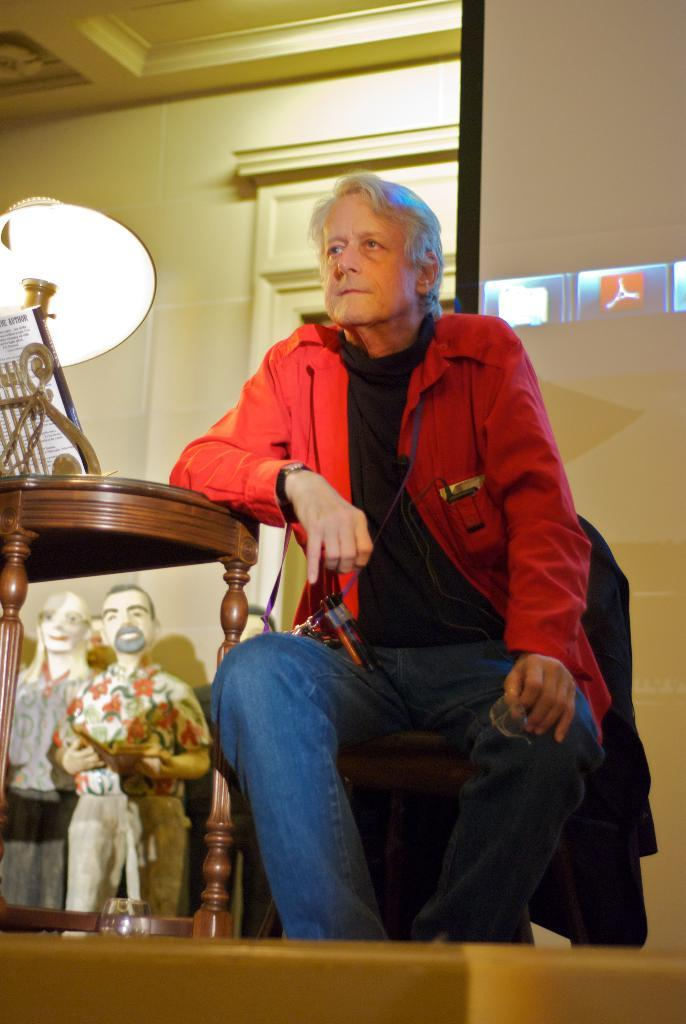What is the person in the image doing? The person is sitting on a chair in the image. What object is near the person? There is a table in the image. What is on the table? A lamp is present on the table. What type of decorative objects can be seen near the table? There are sculptures on or under the table. How many oranges are on the table in the image? There are no oranges present in the image. What is the person's wealth status in the image? The image does not provide any information about the person's wealth status. Who is the person's friend in the image? The image does not show any other people, so it is impossible to determine if the person has a friend present. 